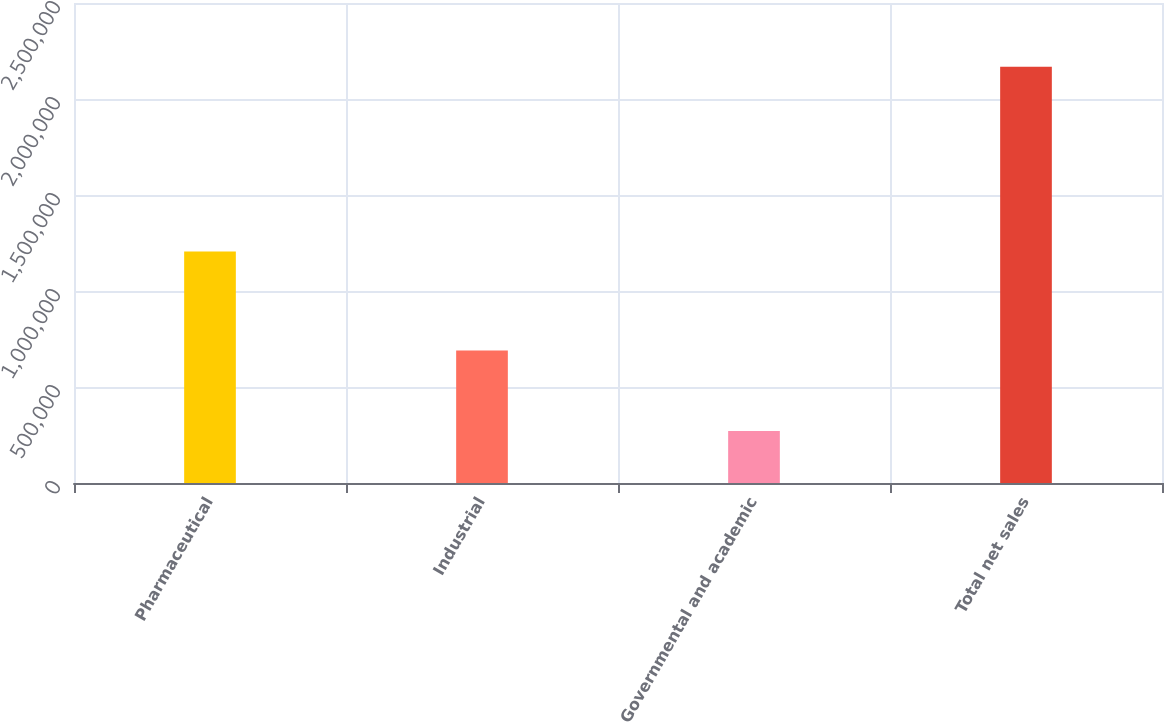<chart> <loc_0><loc_0><loc_500><loc_500><bar_chart><fcel>Pharmaceutical<fcel>Industrial<fcel>Governmental and academic<fcel>Total net sales<nl><fcel>1.20632e+06<fcel>690119<fcel>270988<fcel>2.16742e+06<nl></chart> 